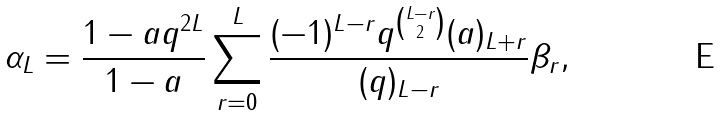<formula> <loc_0><loc_0><loc_500><loc_500>\alpha _ { L } = \frac { 1 - a q ^ { 2 L } } { 1 - a } \sum _ { r = 0 } ^ { L } \frac { ( - 1 ) ^ { L - r } q ^ { \binom { L - r } { 2 } } ( a ) _ { L + r } } { ( q ) _ { L - r } } \beta _ { r } ,</formula> 